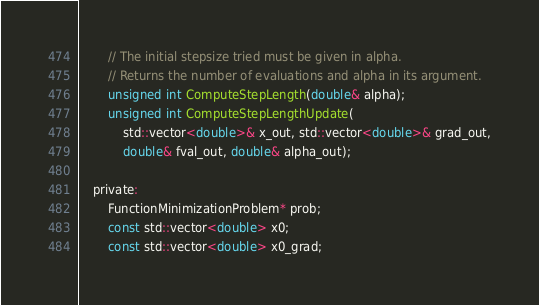Convert code to text. <code><loc_0><loc_0><loc_500><loc_500><_C_>		// The initial stepsize tried must be given in alpha.
		// Returns the number of evaluations and alpha in its argument.
		unsigned int ComputeStepLength(double& alpha);
		unsigned int ComputeStepLengthUpdate(
			std::vector<double>& x_out, std::vector<double>& grad_out,
			double& fval_out, double& alpha_out);

	private:
		FunctionMinimizationProblem* prob;
		const std::vector<double> x0;
		const std::vector<double> x0_grad;</code> 